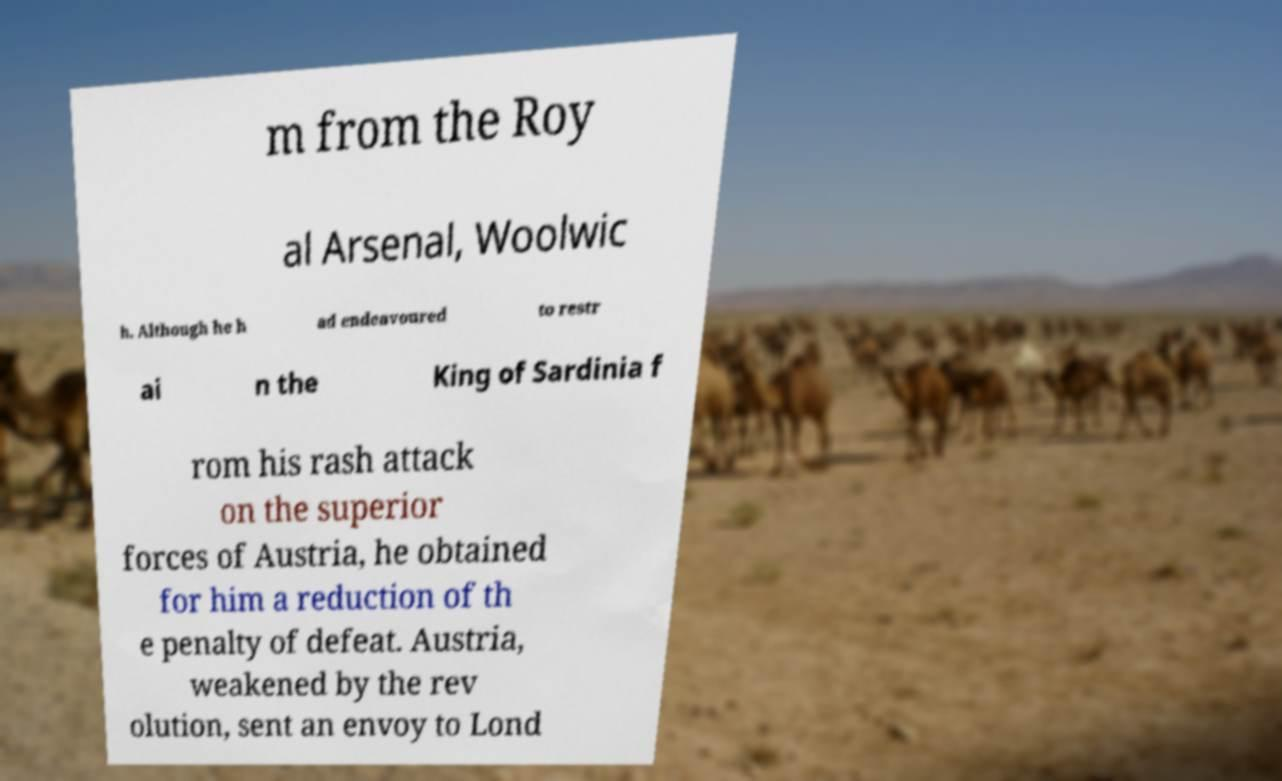Please read and relay the text visible in this image. What does it say? m from the Roy al Arsenal, Woolwic h. Although he h ad endeavoured to restr ai n the King of Sardinia f rom his rash attack on the superior forces of Austria, he obtained for him a reduction of th e penalty of defeat. Austria, weakened by the rev olution, sent an envoy to Lond 